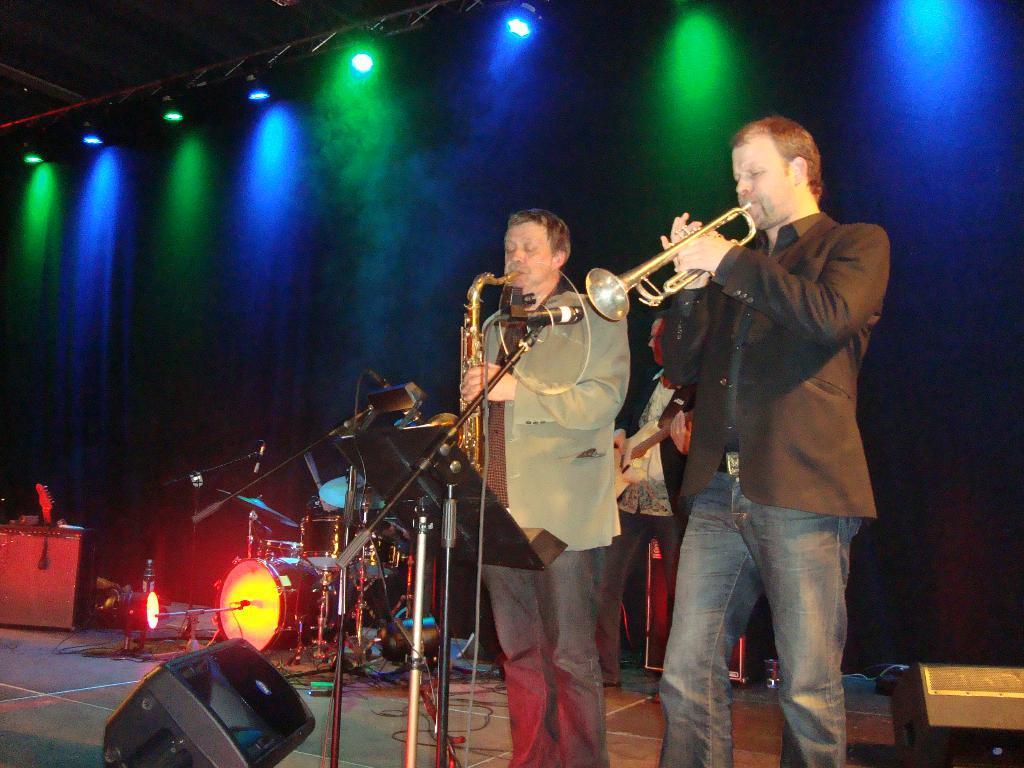Could you give a brief overview of what you see in this image? In this image I can see three people are standing and holding musical instruments. I can also see few mics and a drum set. In the background I can see few lights. 